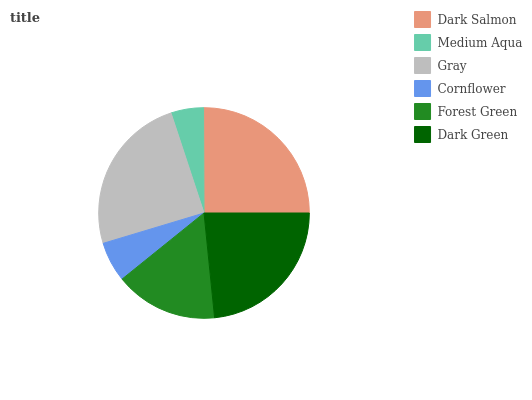Is Medium Aqua the minimum?
Answer yes or no. Yes. Is Dark Salmon the maximum?
Answer yes or no. Yes. Is Gray the minimum?
Answer yes or no. No. Is Gray the maximum?
Answer yes or no. No. Is Gray greater than Medium Aqua?
Answer yes or no. Yes. Is Medium Aqua less than Gray?
Answer yes or no. Yes. Is Medium Aqua greater than Gray?
Answer yes or no. No. Is Gray less than Medium Aqua?
Answer yes or no. No. Is Dark Green the high median?
Answer yes or no. Yes. Is Forest Green the low median?
Answer yes or no. Yes. Is Forest Green the high median?
Answer yes or no. No. Is Dark Green the low median?
Answer yes or no. No. 